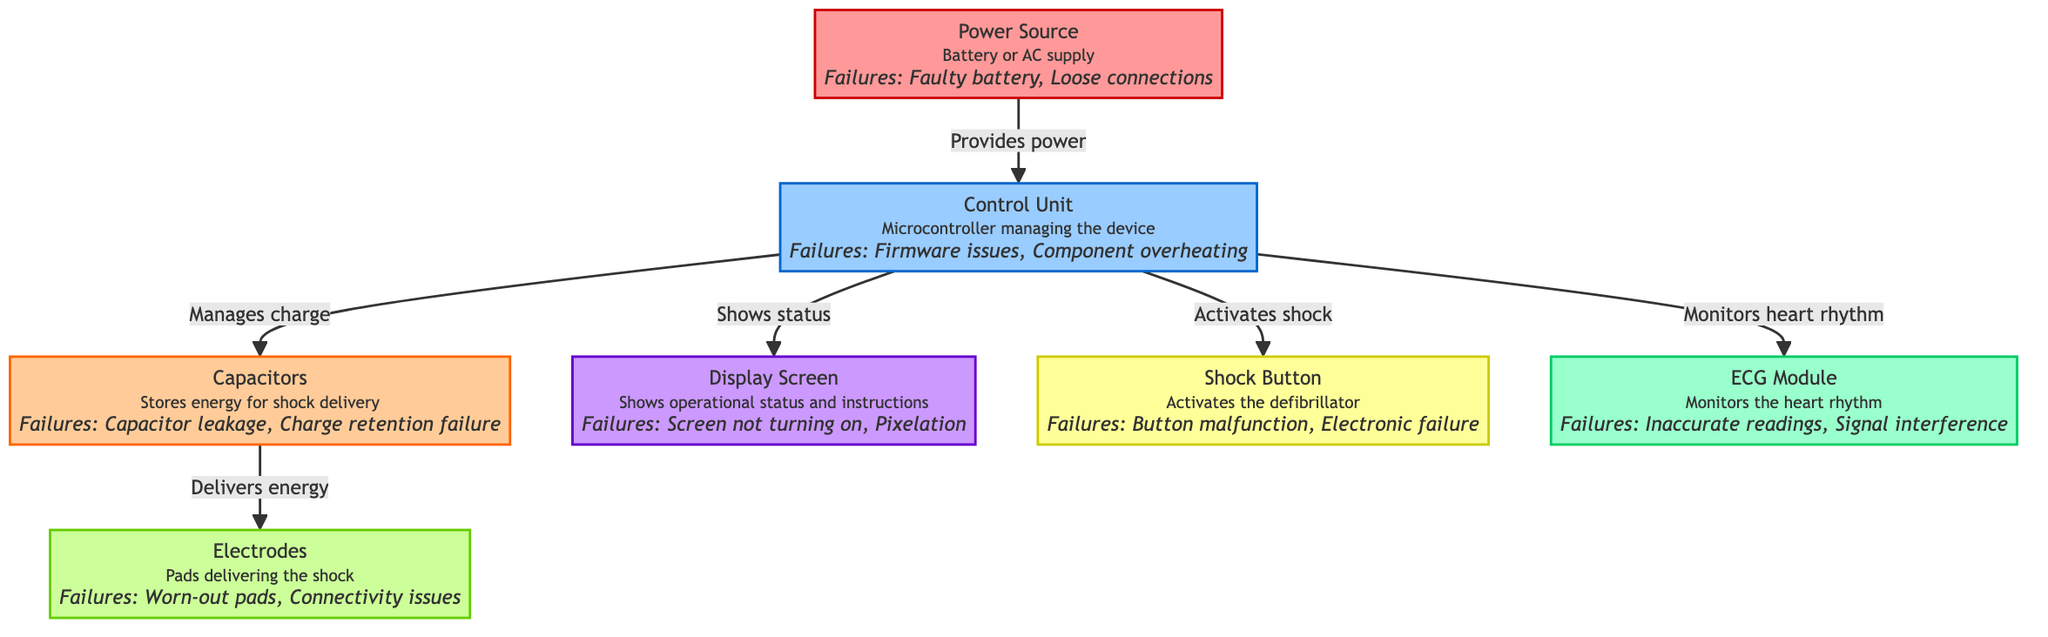What are the two sources of power for the defibrillator? The diagram states that the power sources are either a battery or an AC supply. These are located in the "Power Source" node.
Answer: Battery or AC supply How many failure points are identified in the Control Unit? The "Control Unit" node mentions two specific failure points: firmware issues and component overheating. By counting these points, we find that there are two.
Answer: 2 Which component manages the heart rhythm monitoring? According to the diagram, the ECG Module is responsible for monitoring the heart rhythm, indicated by its direct connection to the Control Unit node.
Answer: ECG Module What is the link between the Control Unit and Capacitors? The diagram indicates that the Control Unit manages the charge to the Capacitors. This is shown by a directed edge from the Control Unit to the Capacitors node, implying a controlling relationship.
Answer: Manages charge What failure is associated with the Capacitors? The diagram highlights two failure points for the Capacitors: capacitor leakage and charge retention failure. We can find these descriptions directly within the Capacitor node.
Answer: Capacitor leakage, Charge retention failure How many components act as interfaces for user interaction? The user interacts with two components: the Shock Button and the Display Screen. We identify these nodes, which are specifically designed for user operation in the diagram.
Answer: 2 Which component directly delivers energy for shock delivery? In the flowchart, it is indicated that the Capacitors deliver energy to the Electrodes. This relationship can be directly traced through the specified connections.
Answer: Electrodes What type of issues might the Display Screen encounter? The diagram outlines that the Display Screen could face two types of issues: not turning on and pixelation, which are explicitly noted in the Display Screen node.
Answer: Not turning on, Pixelation 